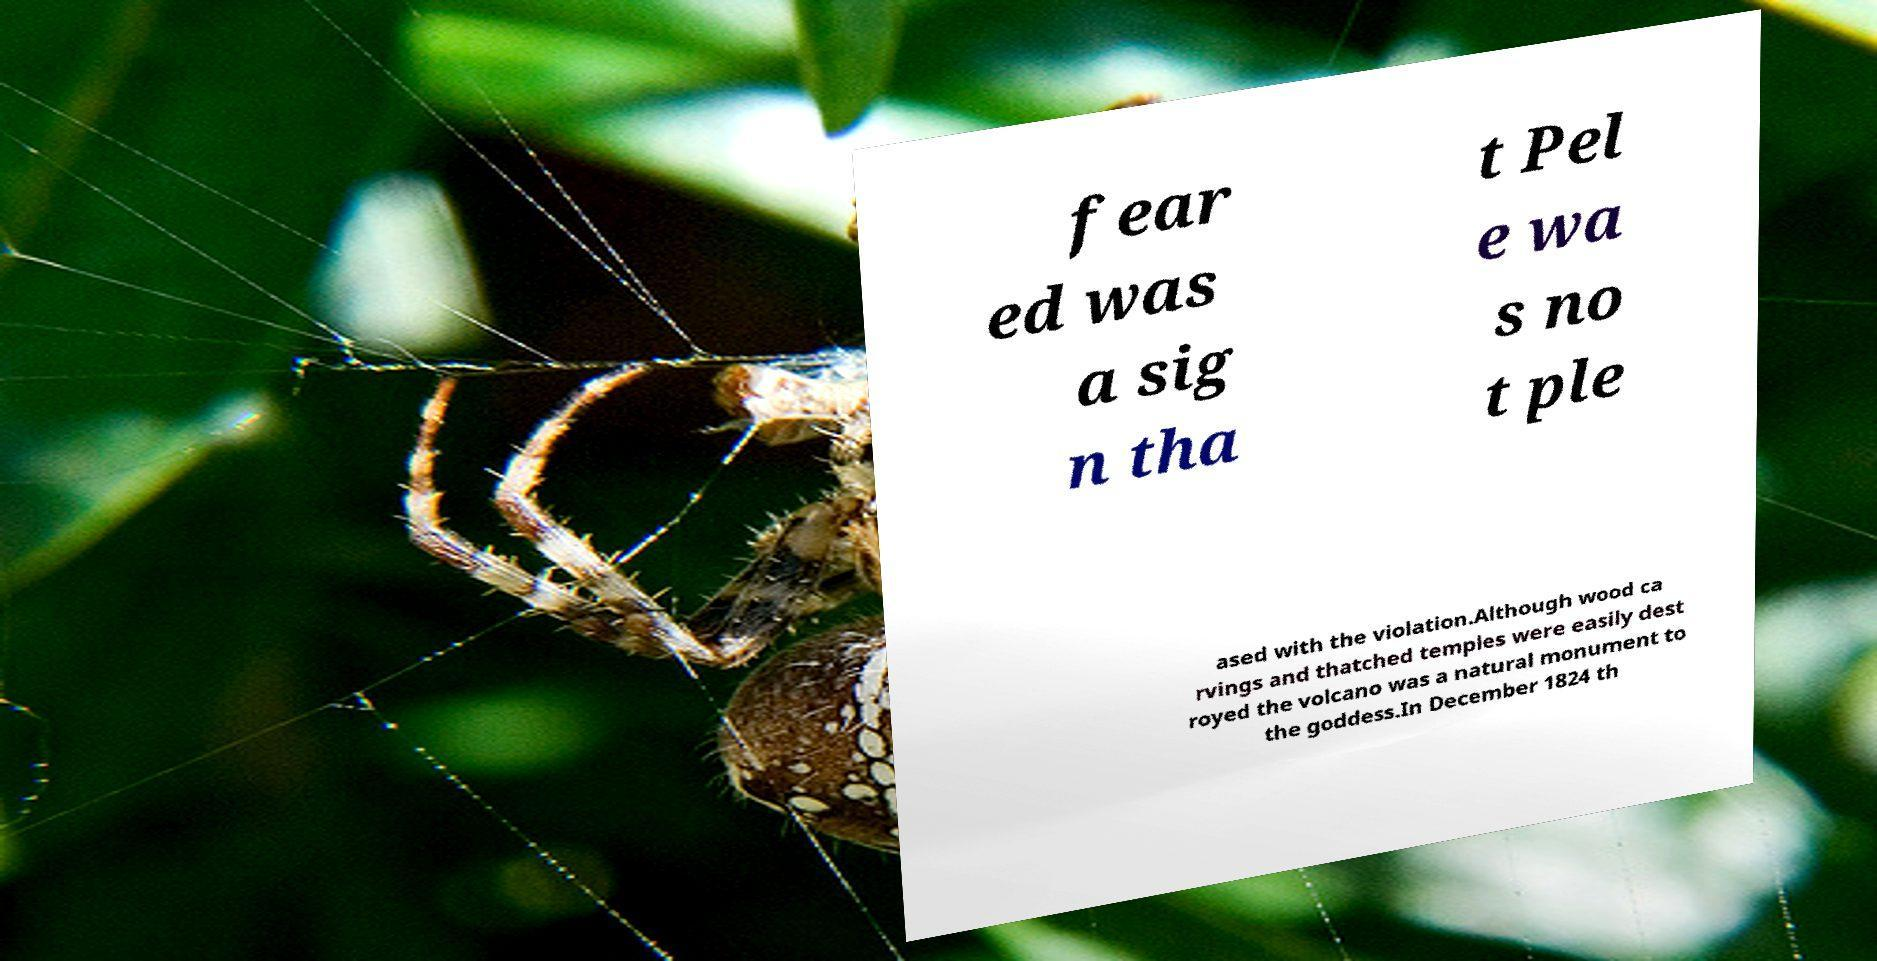Please read and relay the text visible in this image. What does it say? fear ed was a sig n tha t Pel e wa s no t ple ased with the violation.Although wood ca rvings and thatched temples were easily dest royed the volcano was a natural monument to the goddess.In December 1824 th 